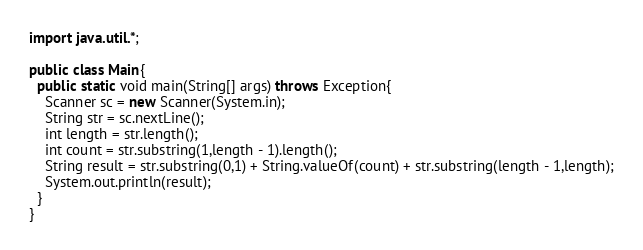<code> <loc_0><loc_0><loc_500><loc_500><_Java_>import java.util.*;

public class Main{
  public static void main(String[] args) throws Exception{
	Scanner sc = new Scanner(System.in);
    String str = sc.nextLine();
    int length = str.length();
    int count = str.substring(1,length - 1).length();
    String result = str.substring(0,1) + String.valueOf(count) + str.substring(length - 1,length);
    System.out.println(result);
  }
}</code> 